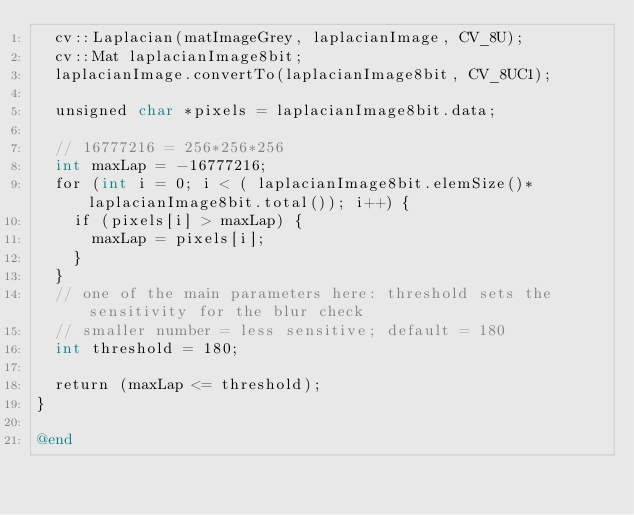<code> <loc_0><loc_0><loc_500><loc_500><_ObjectiveC_>  cv::Laplacian(matImageGrey, laplacianImage, CV_8U);
  cv::Mat laplacianImage8bit;
  laplacianImage.convertTo(laplacianImage8bit, CV_8UC1);
  
  unsigned char *pixels = laplacianImage8bit.data;
  
  // 16777216 = 256*256*256
  int maxLap = -16777216;
  for (int i = 0; i < ( laplacianImage8bit.elemSize()*laplacianImage8bit.total()); i++) {
    if (pixels[i] > maxLap) {
      maxLap = pixels[i];
    }
  }
  // one of the main parameters here: threshold sets the sensitivity for the blur check
  // smaller number = less sensitive; default = 180
  int threshold = 180;
  
  return (maxLap <= threshold);
}

@end
</code> 